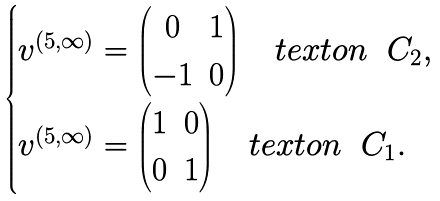Convert formula to latex. <formula><loc_0><loc_0><loc_500><loc_500>\begin{cases} v ^ { ( 5 , \infty ) } = \begin{pmatrix} 0 & 1 \\ - 1 & 0 \end{pmatrix} \quad t e x t { o n } \ \ C _ { 2 } , \\ v ^ { ( 5 , \infty ) } = \begin{pmatrix} 1 & 0 \\ 0 & 1 \end{pmatrix} \quad t e x t { o n } \ \ C _ { 1 } . \end{cases}</formula> 